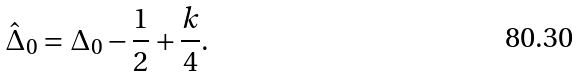Convert formula to latex. <formula><loc_0><loc_0><loc_500><loc_500>\hat { \Delta } _ { 0 } = \Delta _ { 0 } - \frac { 1 } { 2 } + \frac { k } { 4 } .</formula> 